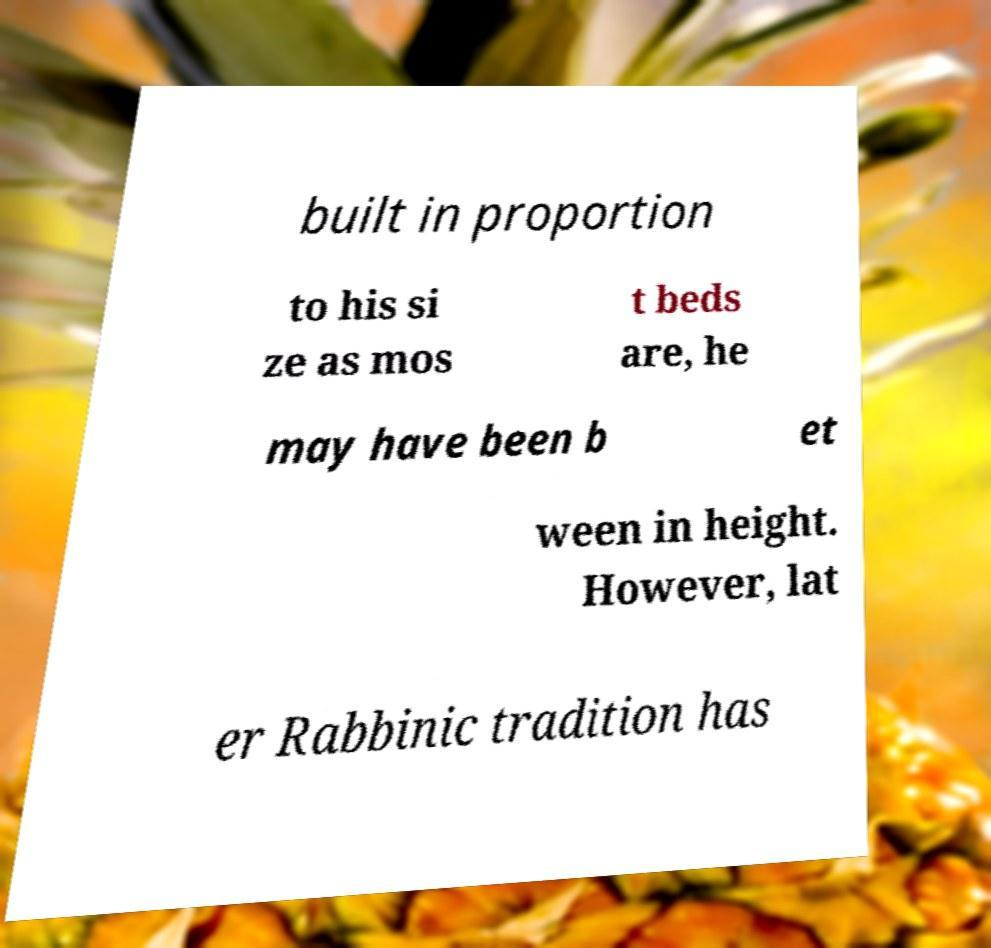For documentation purposes, I need the text within this image transcribed. Could you provide that? built in proportion to his si ze as mos t beds are, he may have been b et ween in height. However, lat er Rabbinic tradition has 